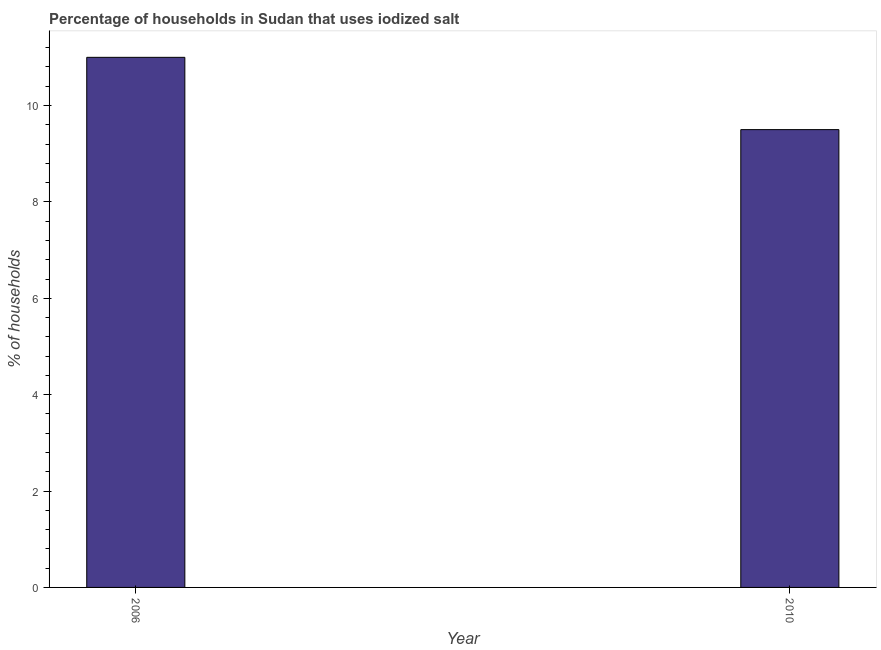Does the graph contain any zero values?
Provide a succinct answer. No. Does the graph contain grids?
Your answer should be very brief. No. What is the title of the graph?
Ensure brevity in your answer.  Percentage of households in Sudan that uses iodized salt. What is the label or title of the X-axis?
Offer a terse response. Year. What is the label or title of the Y-axis?
Offer a terse response. % of households. In which year was the percentage of households where iodized salt is consumed maximum?
Your response must be concise. 2006. What is the average percentage of households where iodized salt is consumed per year?
Your response must be concise. 10.25. What is the median percentage of households where iodized salt is consumed?
Give a very brief answer. 10.25. Do a majority of the years between 2006 and 2010 (inclusive) have percentage of households where iodized salt is consumed greater than 10 %?
Give a very brief answer. No. What is the ratio of the percentage of households where iodized salt is consumed in 2006 to that in 2010?
Your response must be concise. 1.16. How many bars are there?
Provide a short and direct response. 2. How many years are there in the graph?
Give a very brief answer. 2. What is the % of households of 2006?
Make the answer very short. 11. What is the % of households of 2010?
Give a very brief answer. 9.5. What is the ratio of the % of households in 2006 to that in 2010?
Provide a succinct answer. 1.16. 